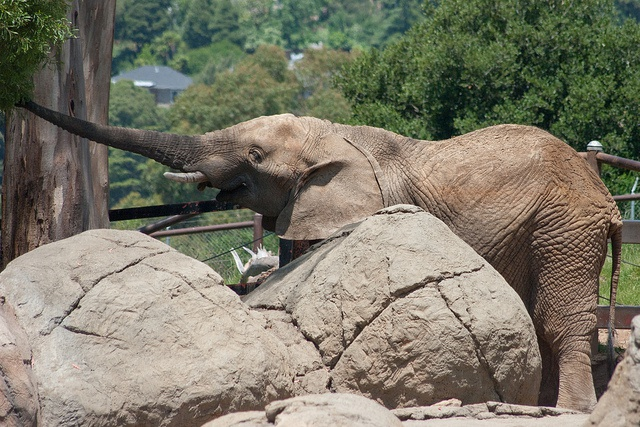Describe the objects in this image and their specific colors. I can see a elephant in darkgreen, black, gray, and tan tones in this image. 